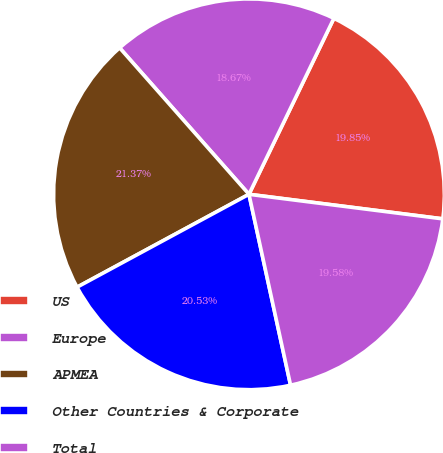Convert chart to OTSL. <chart><loc_0><loc_0><loc_500><loc_500><pie_chart><fcel>US<fcel>Europe<fcel>APMEA<fcel>Other Countries & Corporate<fcel>Total<nl><fcel>19.85%<fcel>18.67%<fcel>21.37%<fcel>20.53%<fcel>19.58%<nl></chart> 